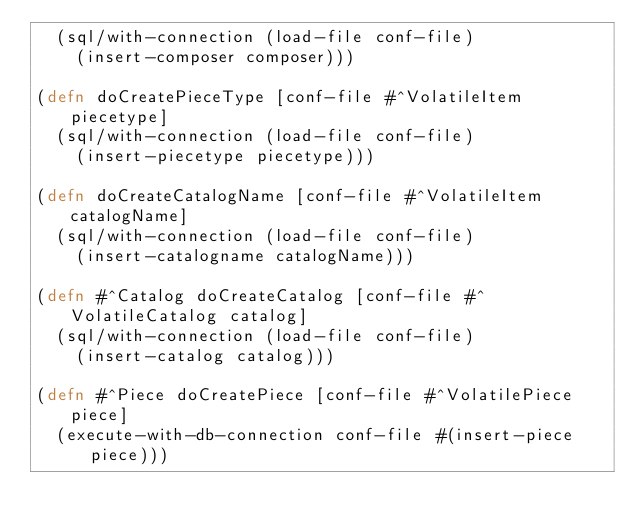Convert code to text. <code><loc_0><loc_0><loc_500><loc_500><_Clojure_>  (sql/with-connection (load-file conf-file)
    (insert-composer composer)))

(defn doCreatePieceType [conf-file #^VolatileItem piecetype]
  (sql/with-connection (load-file conf-file)
    (insert-piecetype piecetype)))

(defn doCreateCatalogName [conf-file #^VolatileItem catalogName]
  (sql/with-connection (load-file conf-file)
    (insert-catalogname catalogName)))

(defn #^Catalog doCreateCatalog [conf-file #^VolatileCatalog catalog]
  (sql/with-connection (load-file conf-file)
    (insert-catalog catalog)))

(defn #^Piece doCreatePiece [conf-file #^VolatilePiece piece]
  (execute-with-db-connection conf-file #(insert-piece piece)))

</code> 